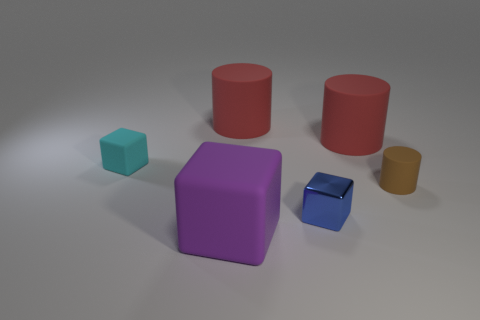The tiny shiny cube is what color?
Offer a terse response. Blue. There is a big matte object in front of the cube that is behind the small brown cylinder; what is its shape?
Keep it short and to the point. Cube. Are there any green spheres made of the same material as the purple thing?
Provide a short and direct response. No. Do the rubber object on the left side of the purple cube and the tiny brown object have the same size?
Your answer should be compact. Yes. What number of cyan objects are small cylinders or small things?
Offer a very short reply. 1. There is a purple block that is on the left side of the tiny rubber cylinder; what is it made of?
Provide a short and direct response. Rubber. How many large red matte things are on the right side of the small block that is to the right of the big purple cube?
Give a very brief answer. 1. How many small brown matte things have the same shape as the blue metallic thing?
Make the answer very short. 0. What number of big purple matte blocks are there?
Make the answer very short. 1. There is a tiny cube in front of the tiny brown rubber cylinder; what is its color?
Offer a very short reply. Blue. 